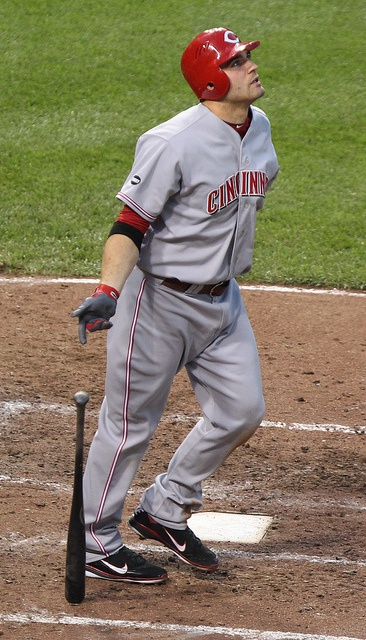Describe the objects in this image and their specific colors. I can see people in olive, darkgray, gray, black, and lavender tones and baseball bat in olive, black, and gray tones in this image. 